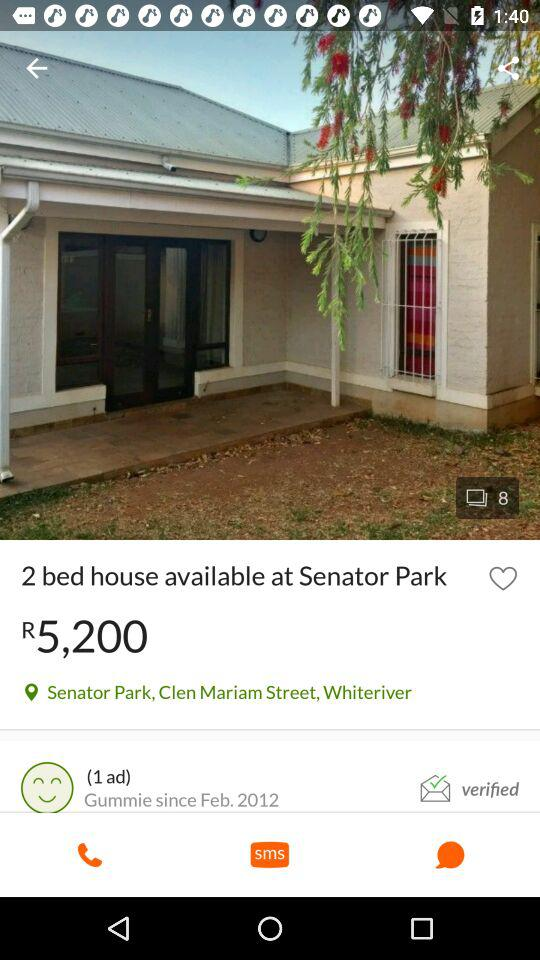How many beds are available in the house at "Senator Park"? The number of beds available in the house is 2. 